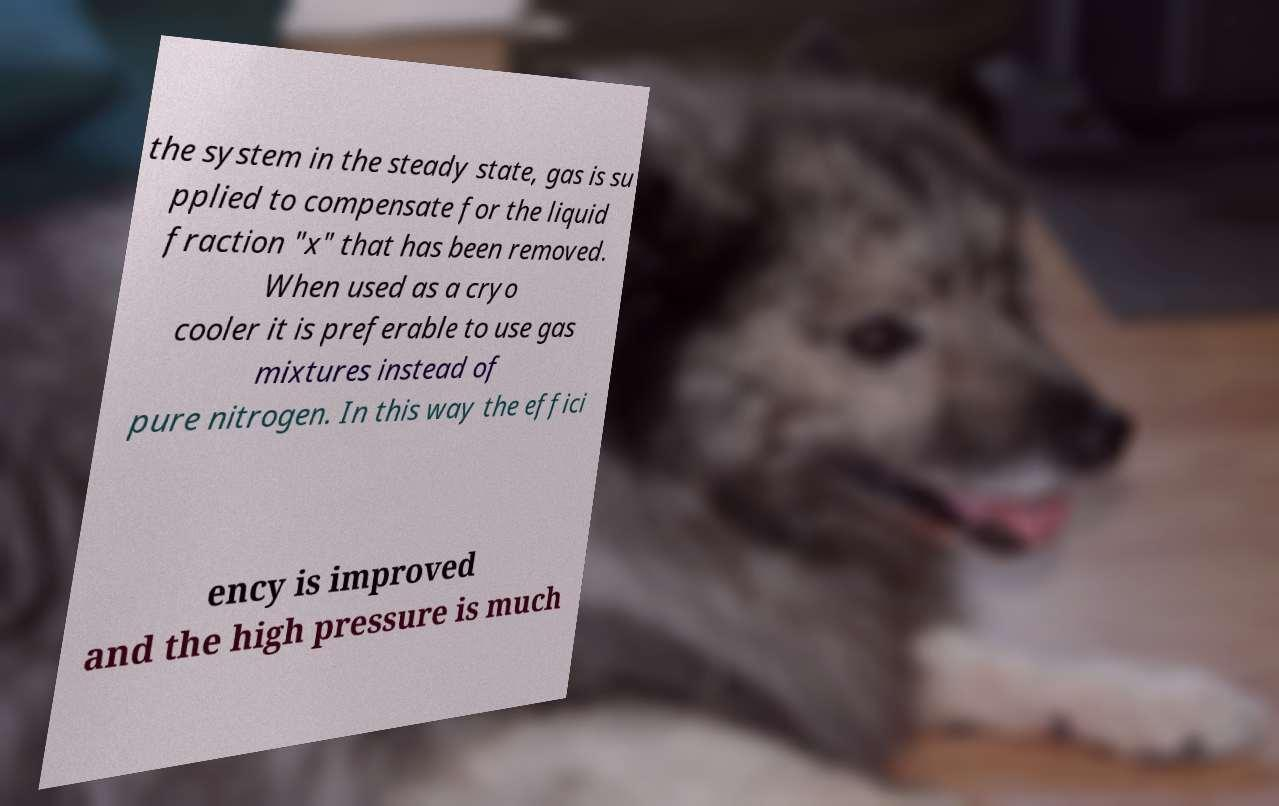Can you read and provide the text displayed in the image?This photo seems to have some interesting text. Can you extract and type it out for me? the system in the steady state, gas is su pplied to compensate for the liquid fraction "x" that has been removed. When used as a cryo cooler it is preferable to use gas mixtures instead of pure nitrogen. In this way the effici ency is improved and the high pressure is much 